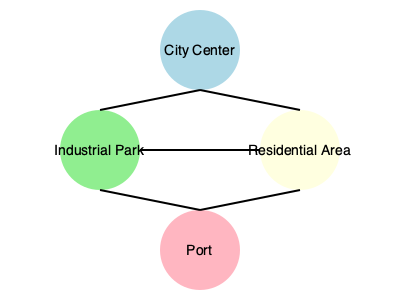Based on the infrastructure network diagram, which area is directly connected to all other areas and serves as the central hub for the city's development projects? To answer this question, we need to analyze the connections between different areas in the infrastructure network diagram:

1. Identify the areas: The diagram shows four main areas - City Center, Industrial Park, Residential Area, and Port.

2. Examine the connections:
   - City Center is connected to Industrial Park and Residential Area
   - Industrial Park is connected to City Center, Residential Area, and Port
   - Residential Area is connected to City Center, Industrial Park, and Port
   - Port is connected to Industrial Park and Residential Area

3. Count the connections:
   - City Center: 2 connections
   - Industrial Park: 3 connections
   - Residential Area: 3 connections
   - Port: 2 connections

4. Identify the central hub: The area with the most connections (3) that is also positioned centrally in the diagram is the Industrial Park.

5. Consider the implications: The Industrial Park's central position and multiple connections suggest it plays a crucial role in the city's infrastructure and development projects, linking the City Center, Residential Area, and Port.
Answer: Industrial Park 